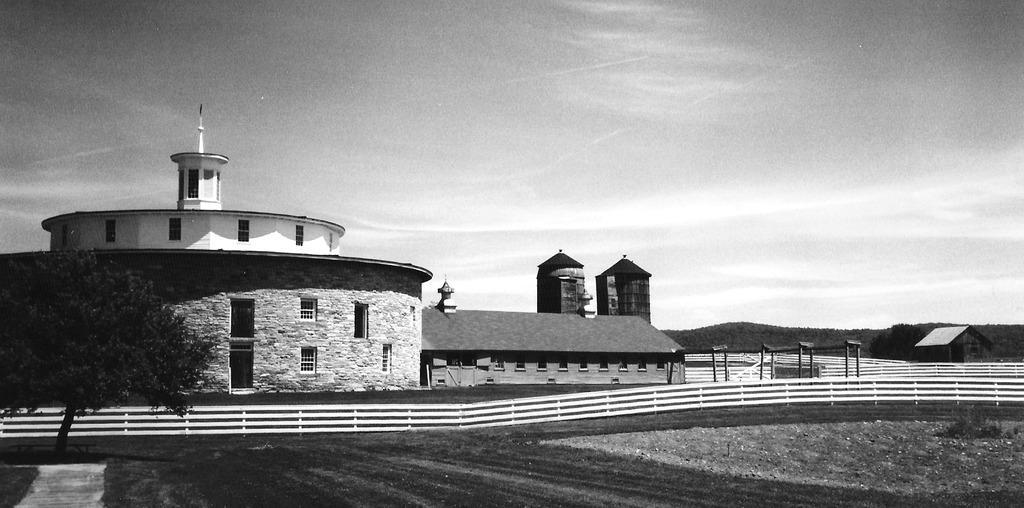How would you summarize this image in a sentence or two? This is a black and white picture. At the bottom, we see the road and the road railing. On the left side, we see a tree. There are buildings and poles in the background. On the right side, we see a tree and a hut. There are hills in the background. At the top, we see the sky. 